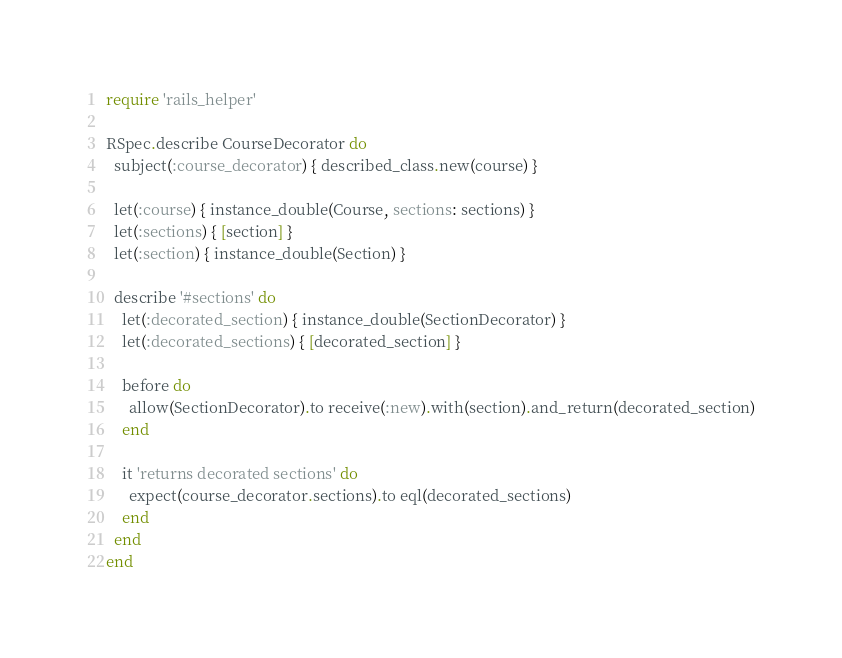Convert code to text. <code><loc_0><loc_0><loc_500><loc_500><_Ruby_>require 'rails_helper'

RSpec.describe CourseDecorator do
  subject(:course_decorator) { described_class.new(course) }

  let(:course) { instance_double(Course, sections: sections) }
  let(:sections) { [section] }
  let(:section) { instance_double(Section) }

  describe '#sections' do
    let(:decorated_section) { instance_double(SectionDecorator) }
    let(:decorated_sections) { [decorated_section] }

    before do
      allow(SectionDecorator).to receive(:new).with(section).and_return(decorated_section)
    end

    it 'returns decorated sections' do
      expect(course_decorator.sections).to eql(decorated_sections)
    end
  end
end
</code> 